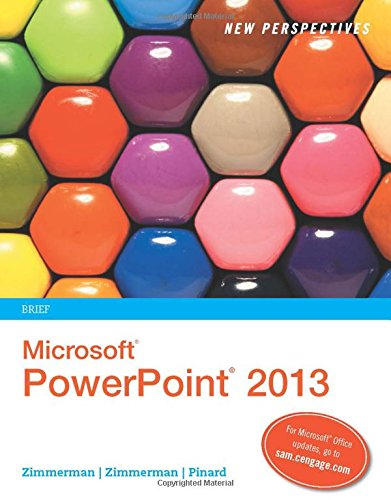Who is the author of this book? The author of the book displayed in the image is S. Scott Zimmerman, along with Beverley B. Zimmerman and June Jamrich Parsons. 